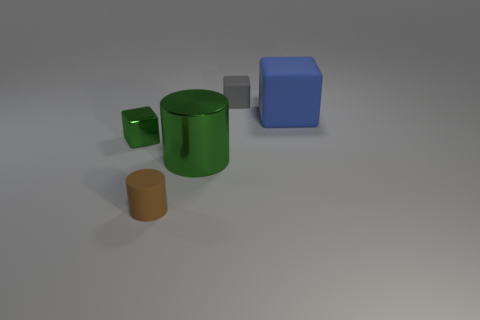Add 1 small brown rubber cubes. How many objects exist? 6 Subtract all blocks. How many objects are left? 2 Add 3 tiny gray blocks. How many tiny gray blocks exist? 4 Subtract 0 cyan balls. How many objects are left? 5 Subtract all tiny yellow rubber cylinders. Subtract all matte objects. How many objects are left? 2 Add 3 brown objects. How many brown objects are left? 4 